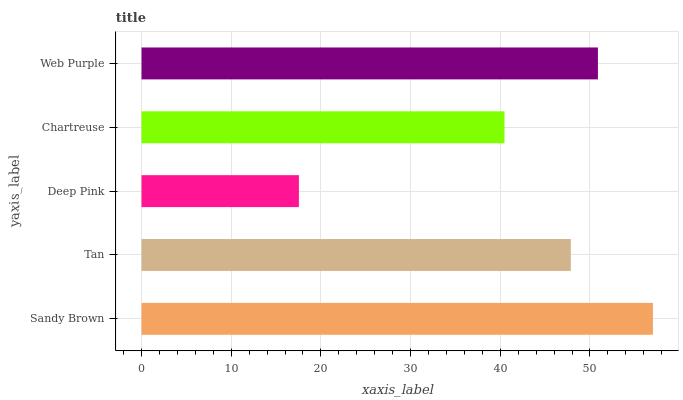Is Deep Pink the minimum?
Answer yes or no. Yes. Is Sandy Brown the maximum?
Answer yes or no. Yes. Is Tan the minimum?
Answer yes or no. No. Is Tan the maximum?
Answer yes or no. No. Is Sandy Brown greater than Tan?
Answer yes or no. Yes. Is Tan less than Sandy Brown?
Answer yes or no. Yes. Is Tan greater than Sandy Brown?
Answer yes or no. No. Is Sandy Brown less than Tan?
Answer yes or no. No. Is Tan the high median?
Answer yes or no. Yes. Is Tan the low median?
Answer yes or no. Yes. Is Chartreuse the high median?
Answer yes or no. No. Is Deep Pink the low median?
Answer yes or no. No. 